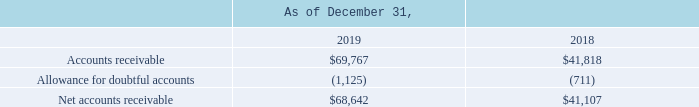(3) Accounts Receivable, Net
Accounts receivable, net, is as follows (in thousands):
Bad debt expense for the years ended December 31, 2019, 2018 and 2017 was $0.7 million, $0.1 million and $0.6 million, respectively.
How much was the Bad debt expense for the years ended December 31, 2019? $0.7 million. How much was the Bad debt expense for the years ended December 31, 2018? $0.1 million. How much was the Bad debt expense for the years ended December 31, 2017? $0.6 million. What is the change in Accounts receivable from December 31, 2019 to December 31, 2018?
Answer scale should be: thousand. 69,767-41,818
Answer: 27949. What is the change in Allowance for doubtful accounts from December 31, 2019 to December 31, 2018?
Answer scale should be: thousand. 1,125-711
Answer: 414. What is the change in Net accounts receivable from December 31, 2019 to December 31, 2018?
Answer scale should be: thousand. 68,642-41,107
Answer: 27535. 